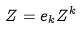Convert formula to latex. <formula><loc_0><loc_0><loc_500><loc_500>Z = e _ { k } Z ^ { k }</formula> 